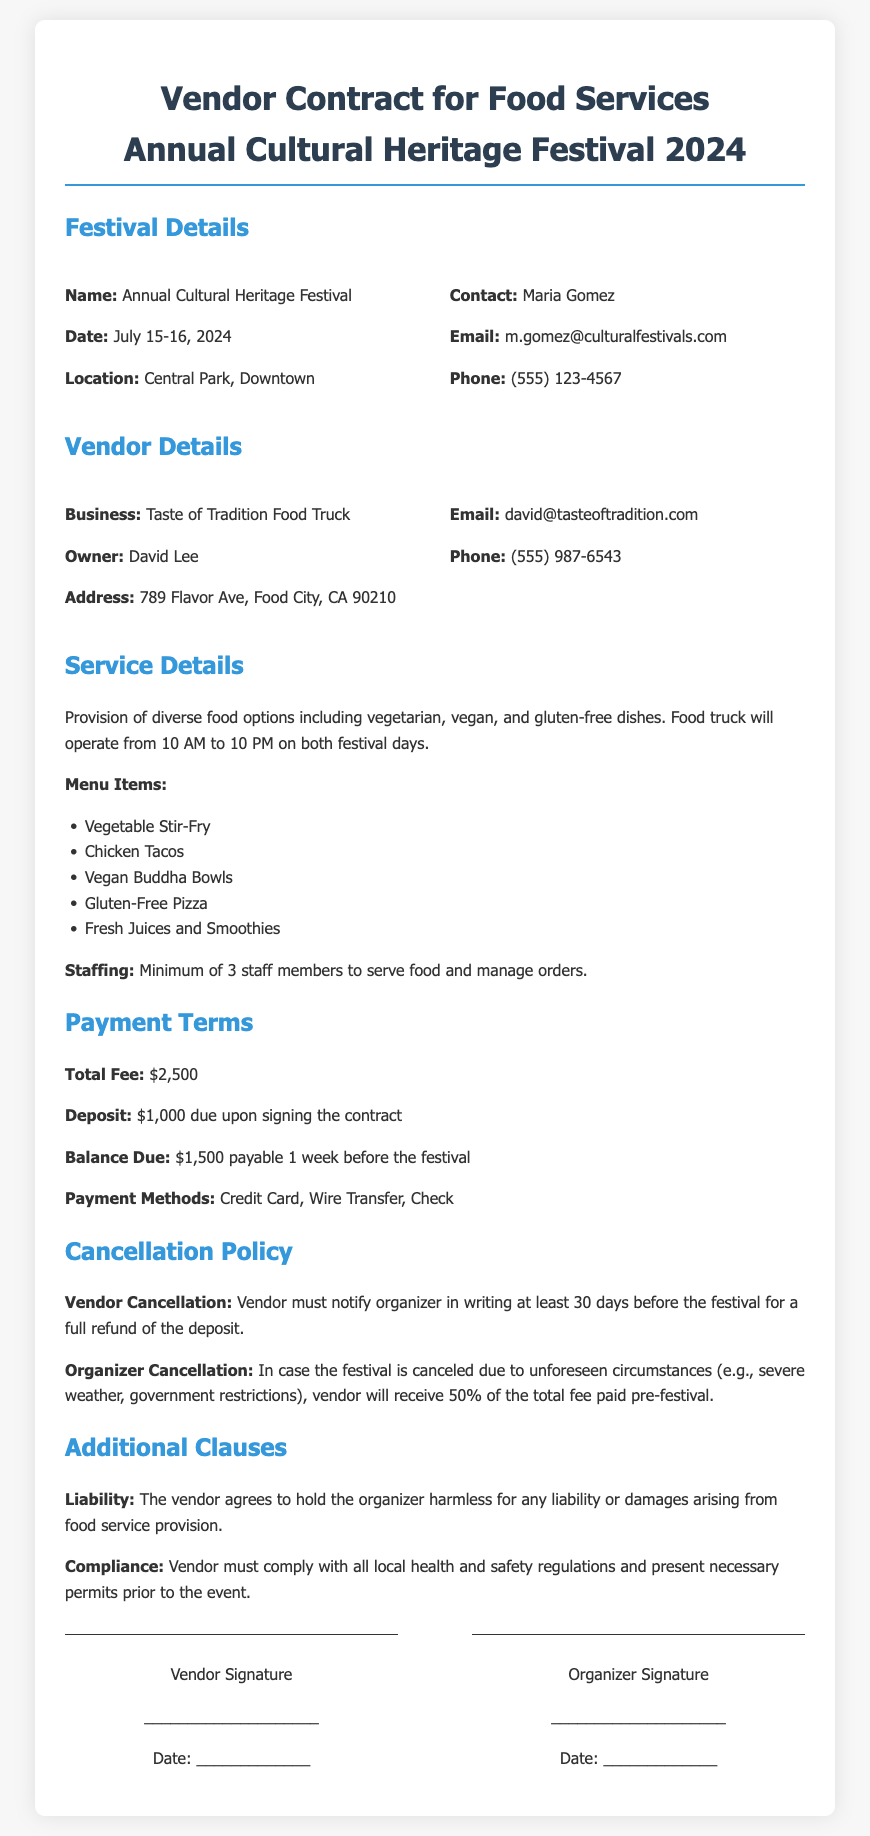what is the total fee for the vendor services? The total fee is stated in the Payment Terms section, specifically noting the fee due for vendor services.
Answer: $2,500 what is the cancellation notice period for a full refund of the deposit? The cancellation policy specifies that the vendor must notify the organizer in writing, indicating the time frame required for a full refund.
Answer: 30 days who is the owner of the vendor business? The vendor details section identifies the owner of the vendor business, providing a specific name for reference.
Answer: David Lee when will the food truck operate during the festival? The service details mention the operational hours for the food truck on the festival days, revealing when services will be available.
Answer: 10 AM to 10 PM what percentage of the total fee will the vendor receive if the festival is canceled by the organizer? The cancellation policy outlines the specifics regarding funds returned to the vendor in the event of festival cancellation by the organizer.
Answer: 50% how many staff members are required to serve food? The service details stipulate a minimum number of staff needed for the food service during the event, indicating the team size necessary for operation.
Answer: 3 staff members what types of payment methods are accepted? The payment terms specify the various methods that can be used to fulfill the payment obligations, detailing the accepted forms of transaction.
Answer: Credit Card, Wire Transfer, Check what is the address of the vendor business? The vendor details section provides the full address of the vendor business, allowing for location identification.
Answer: 789 Flavor Ave, Food City, CA 90210 what are the dates of the cultural festival? The festival details outline the specific dates for the event, providing clarity on when the festival will take place.
Answer: July 15-16, 2024 